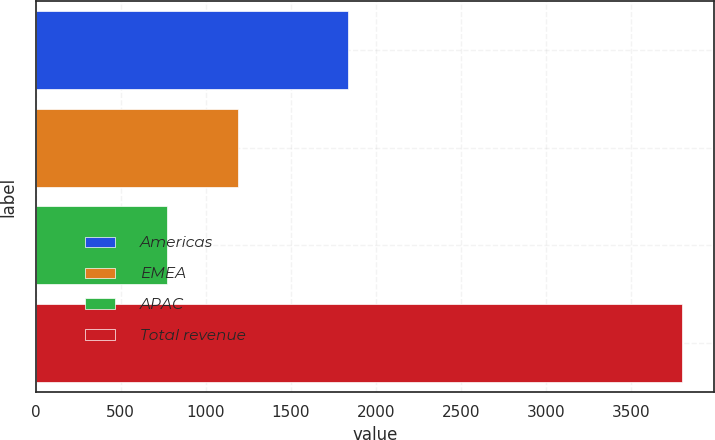<chart> <loc_0><loc_0><loc_500><loc_500><bar_chart><fcel>Americas<fcel>EMEA<fcel>APAC<fcel>Total revenue<nl><fcel>1835.3<fcel>1191.9<fcel>772.8<fcel>3800<nl></chart> 